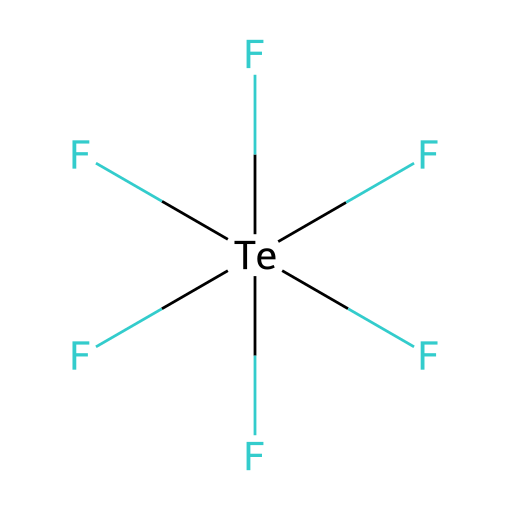What is the chemical name of this compound? The provided SMILES representation corresponds to a compound where a tellurium atom is central, bonded to six fluorine atoms. Therefore, its chemical name is tellurium hexafluoride.
Answer: tellurium hexafluoride How many fluorine atoms are attached to tellurium? By analyzing the structure from the SMILES, we can see that there are six fluorine (F) atoms directly bonded to the tellurium (Te) atom.
Answer: six What is the hybridization of the tellurium atom? In tellurium hexafluoride, the tellurium atom forms six equivalent bonds with fluorine. This indicates that it undergoes sp³d² hybridization to accommodate six bonding pairs.
Answer: sp³d² Is tellurium hexafluoride a hypervalent compound? Hypervalent compounds are characterized by having a central atom that forms more bonds than allowed by the octet rule. Tellurium, having six bonds (which exceeds the octet), confirms that this compound is hypervalent.
Answer: yes What type of chemical compound is this with respect to its molecular geometry? The arrangement of six fluorine atoms around the tellurium atom leads to a distorted octahedral molecular geometry due to the presence of lone pairs and bond angle variations.
Answer: distorted octahedral How does the presence of six bonds affect the stability of tellurium hexafluoride? The presence of six bonds results in a strong bond network; however, such hypervalent compounds can exhibit dynamic behavior due to bond strain and steric interactions among the bulky fluorine atoms.
Answer: bond strain What role does tellurium hexafluoride play in semiconductor production? Tellurium hexafluoride is utilized in semiconductor manufacturing as a source of tellurium and fluorine, critical for forming certain thin films and etching processes.
Answer: source of tellurium and fluorine 